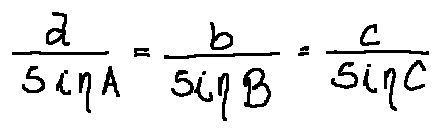Convert formula to latex. <formula><loc_0><loc_0><loc_500><loc_500>\frac { a } { \sin A } = \frac { b } { \sin B } = \frac { c } { \sin C }</formula> 